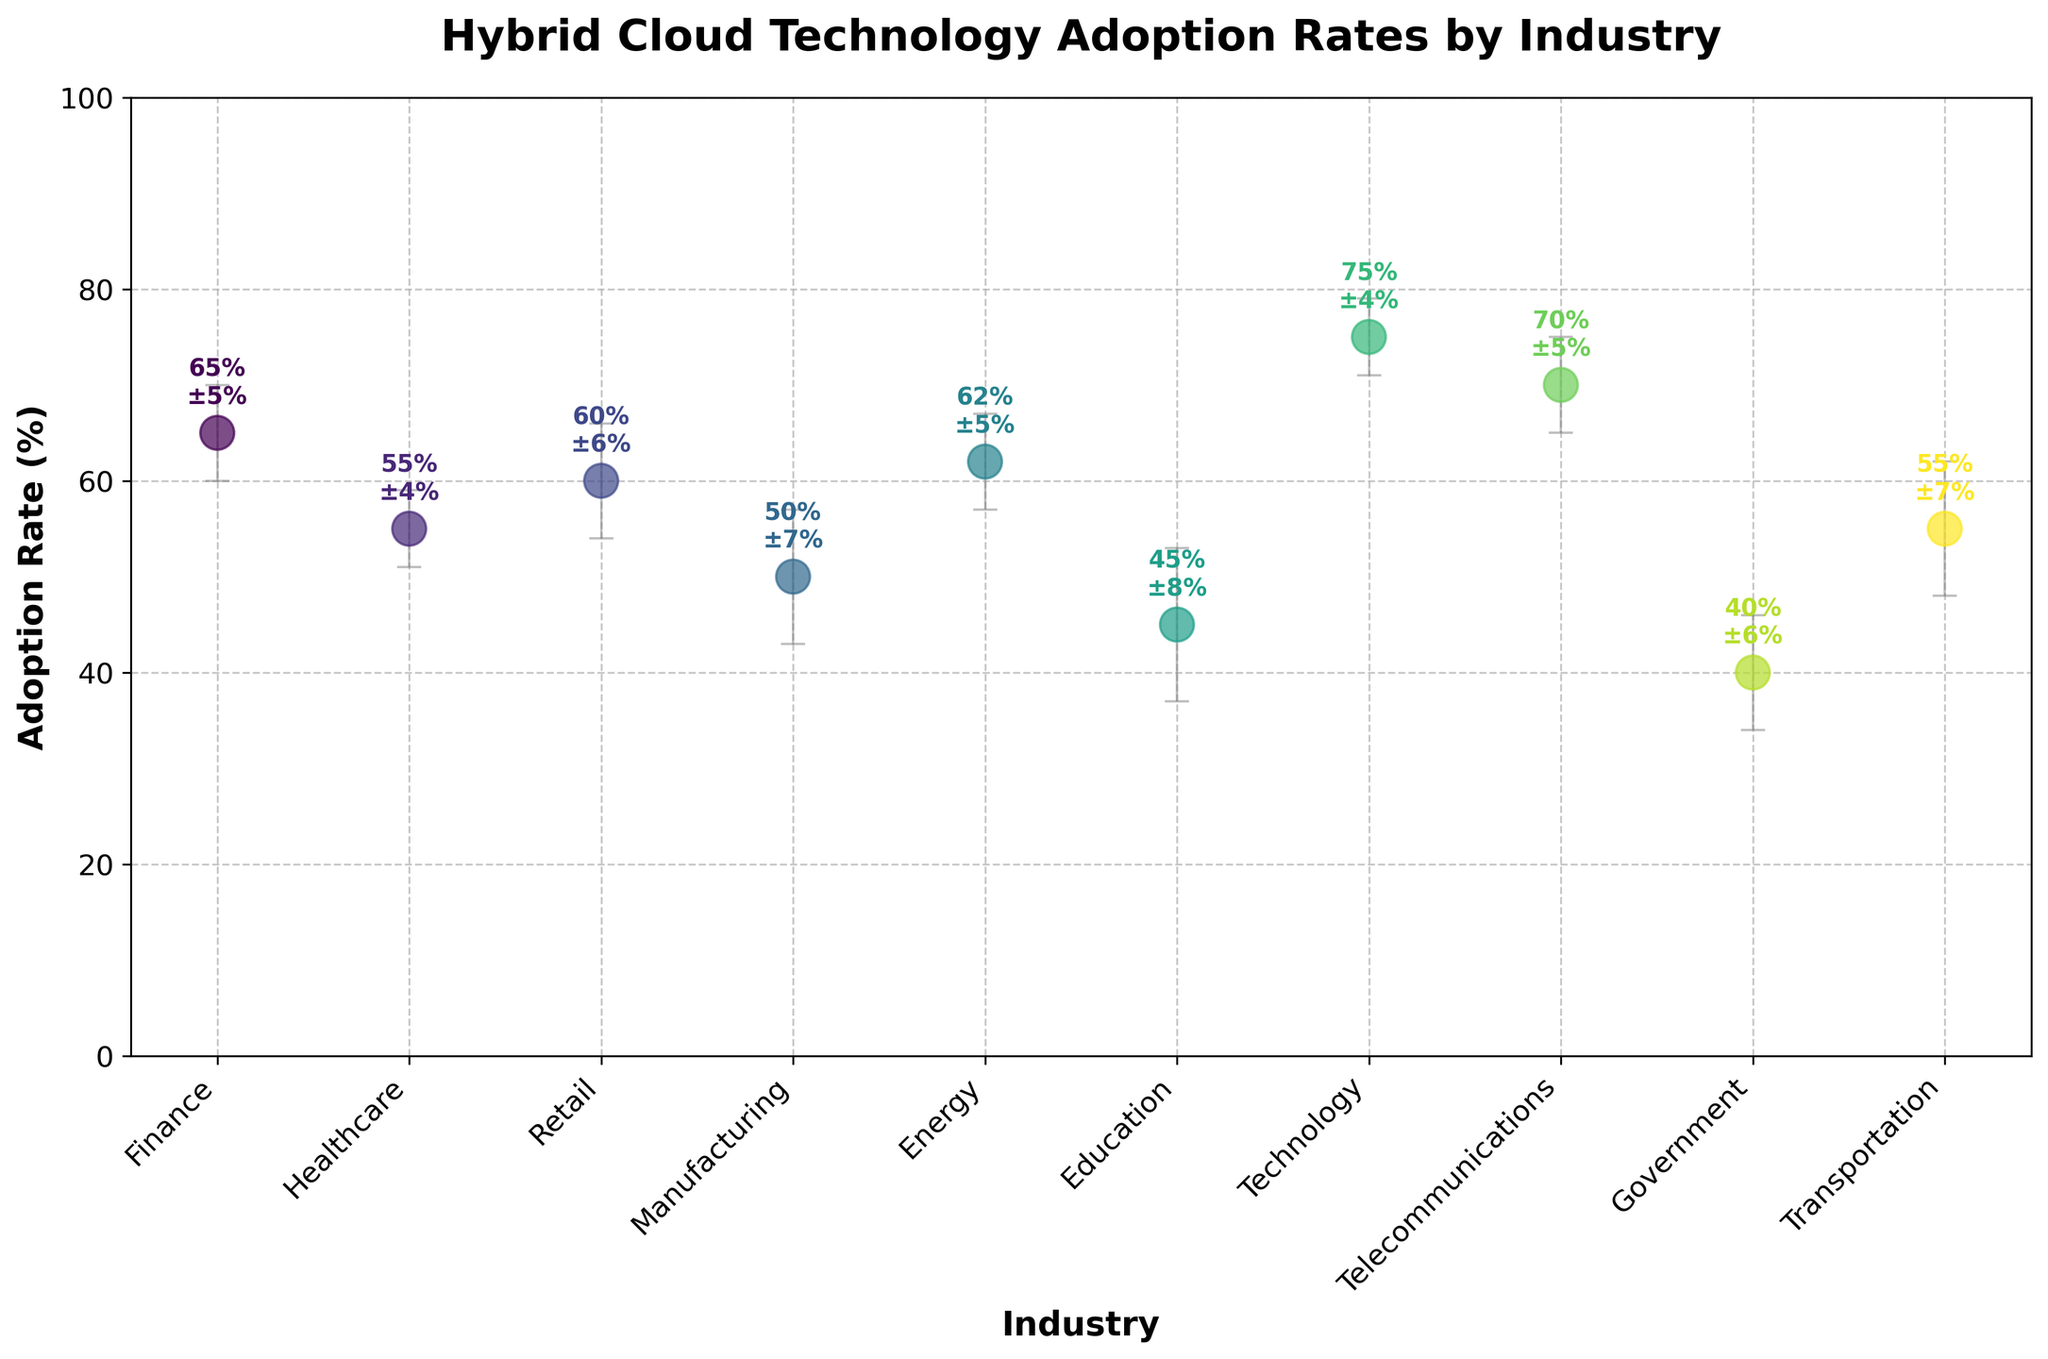What is the title of the figure? The title is displayed at the top of the figure, indicating the main focus of the plot. It reads "Hybrid Cloud Technology Adoption Rates by Industry".
Answer: Hybrid Cloud Technology Adoption Rates by Industry What is the adoption rate for the Finance industry? Locate the Finance industry on the x-axis and refer to its corresponding point and annotation to find the adoption rate.
Answer: 65% Which industry has the highest adoption rate of hybrid cloud technologies? Locate all the data points and identify the one with the highest value on the y-axis. The Technology industry has the highest adoption rate.
Answer: Technology Which industry has the lowest adoption rate, and what is that rate? The Government industry is positioned at the lowest point on the y-axis. Its adoption rate is provided as an annotation next to the point.
Answer: Government, 40% What is the average adoption rate across all industries? Add up all the adoption rates for each industry and divide by the number of industries (10). Calculation: (65 + 55 + 60 + 50 + 62 + 45 + 75 + 70 + 40 + 55) / 10 = 577 / 10 = 57.7%.
Answer: 57.7% Which industry has the largest standard deviation in adoption rates? Check the error bars and annotations to compare the standard deviations. The Education industry has the largest standard deviation.
Answer: Education How does the adoption rate for Healthcare compare to Retail? Compare the y-values of the Healthcare and Retail points. The Healthcare adoption rate (55%) is slightly lower than Retail’s (60%).
Answer: Healthcare is lower What is the range of adoption rates across all industries? Identify the highest and lowest adoption rates, then calculate the difference: 75 (Technology) - 40 (Government) = 35%.
Answer: 35% How many industries have an adoption rate of 60% or above? Count the industries with adoption rates of 60% or greater. The industries are Finance (65), Retail (60), Energy (62), Technology (75), and Telecommunications (70).
Answer: 5 What is the adoption rate plus standard deviation for the Transportation industry? Locate the Transportation industry and add its adoption rate and standard deviation: 55% + 7% = 62%.
Answer: 62% 